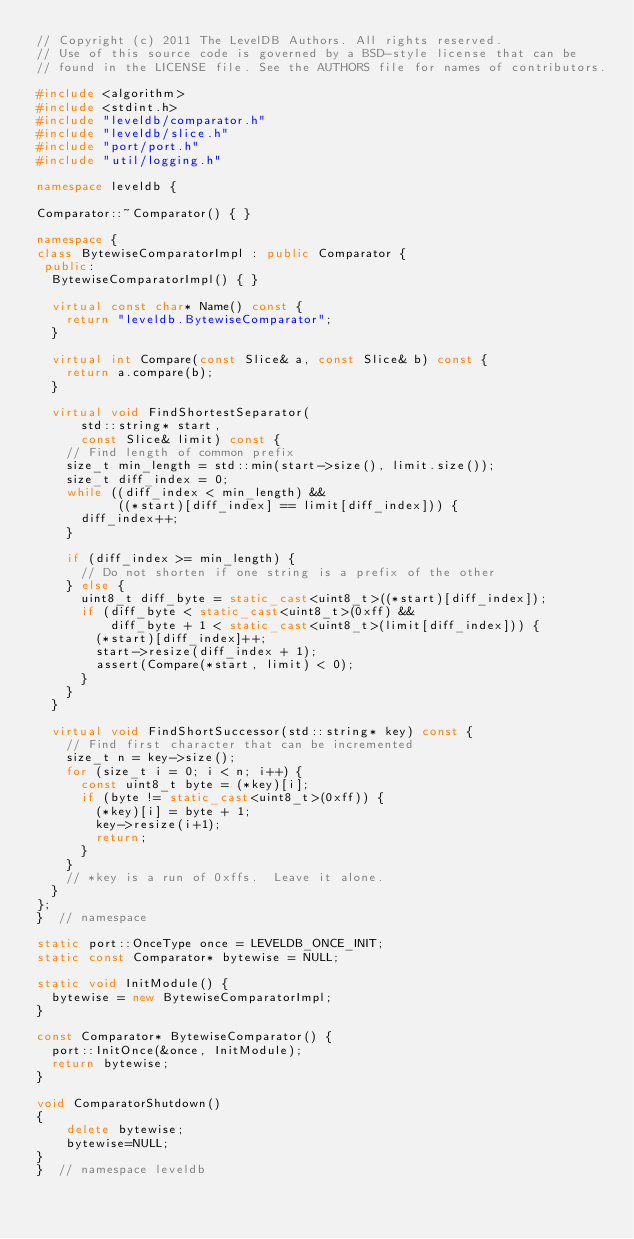<code> <loc_0><loc_0><loc_500><loc_500><_C++_>// Copyright (c) 2011 The LevelDB Authors. All rights reserved.
// Use of this source code is governed by a BSD-style license that can be
// found in the LICENSE file. See the AUTHORS file for names of contributors.

#include <algorithm>
#include <stdint.h>
#include "leveldb/comparator.h"
#include "leveldb/slice.h"
#include "port/port.h"
#include "util/logging.h"

namespace leveldb {

Comparator::~Comparator() { }

namespace {
class BytewiseComparatorImpl : public Comparator {
 public:
  BytewiseComparatorImpl() { }

  virtual const char* Name() const {
    return "leveldb.BytewiseComparator";
  }

  virtual int Compare(const Slice& a, const Slice& b) const {
    return a.compare(b);
  }

  virtual void FindShortestSeparator(
      std::string* start,
      const Slice& limit) const {
    // Find length of common prefix
    size_t min_length = std::min(start->size(), limit.size());
    size_t diff_index = 0;
    while ((diff_index < min_length) &&
           ((*start)[diff_index] == limit[diff_index])) {
      diff_index++;
    }

    if (diff_index >= min_length) {
      // Do not shorten if one string is a prefix of the other
    } else {
      uint8_t diff_byte = static_cast<uint8_t>((*start)[diff_index]);
      if (diff_byte < static_cast<uint8_t>(0xff) &&
          diff_byte + 1 < static_cast<uint8_t>(limit[diff_index])) {
        (*start)[diff_index]++;
        start->resize(diff_index + 1);
        assert(Compare(*start, limit) < 0);
      }
    }
  }

  virtual void FindShortSuccessor(std::string* key) const {
    // Find first character that can be incremented
    size_t n = key->size();
    for (size_t i = 0; i < n; i++) {
      const uint8_t byte = (*key)[i];
      if (byte != static_cast<uint8_t>(0xff)) {
        (*key)[i] = byte + 1;
        key->resize(i+1);
        return;
      }
    }
    // *key is a run of 0xffs.  Leave it alone.
  }
};
}  // namespace

static port::OnceType once = LEVELDB_ONCE_INIT;
static const Comparator* bytewise = NULL;

static void InitModule() {
  bytewise = new BytewiseComparatorImpl;
}

const Comparator* BytewiseComparator() {
  port::InitOnce(&once, InitModule);
  return bytewise;
}

void ComparatorShutdown()
{
    delete bytewise;
    bytewise=NULL;
}
}  // namespace leveldb
</code> 